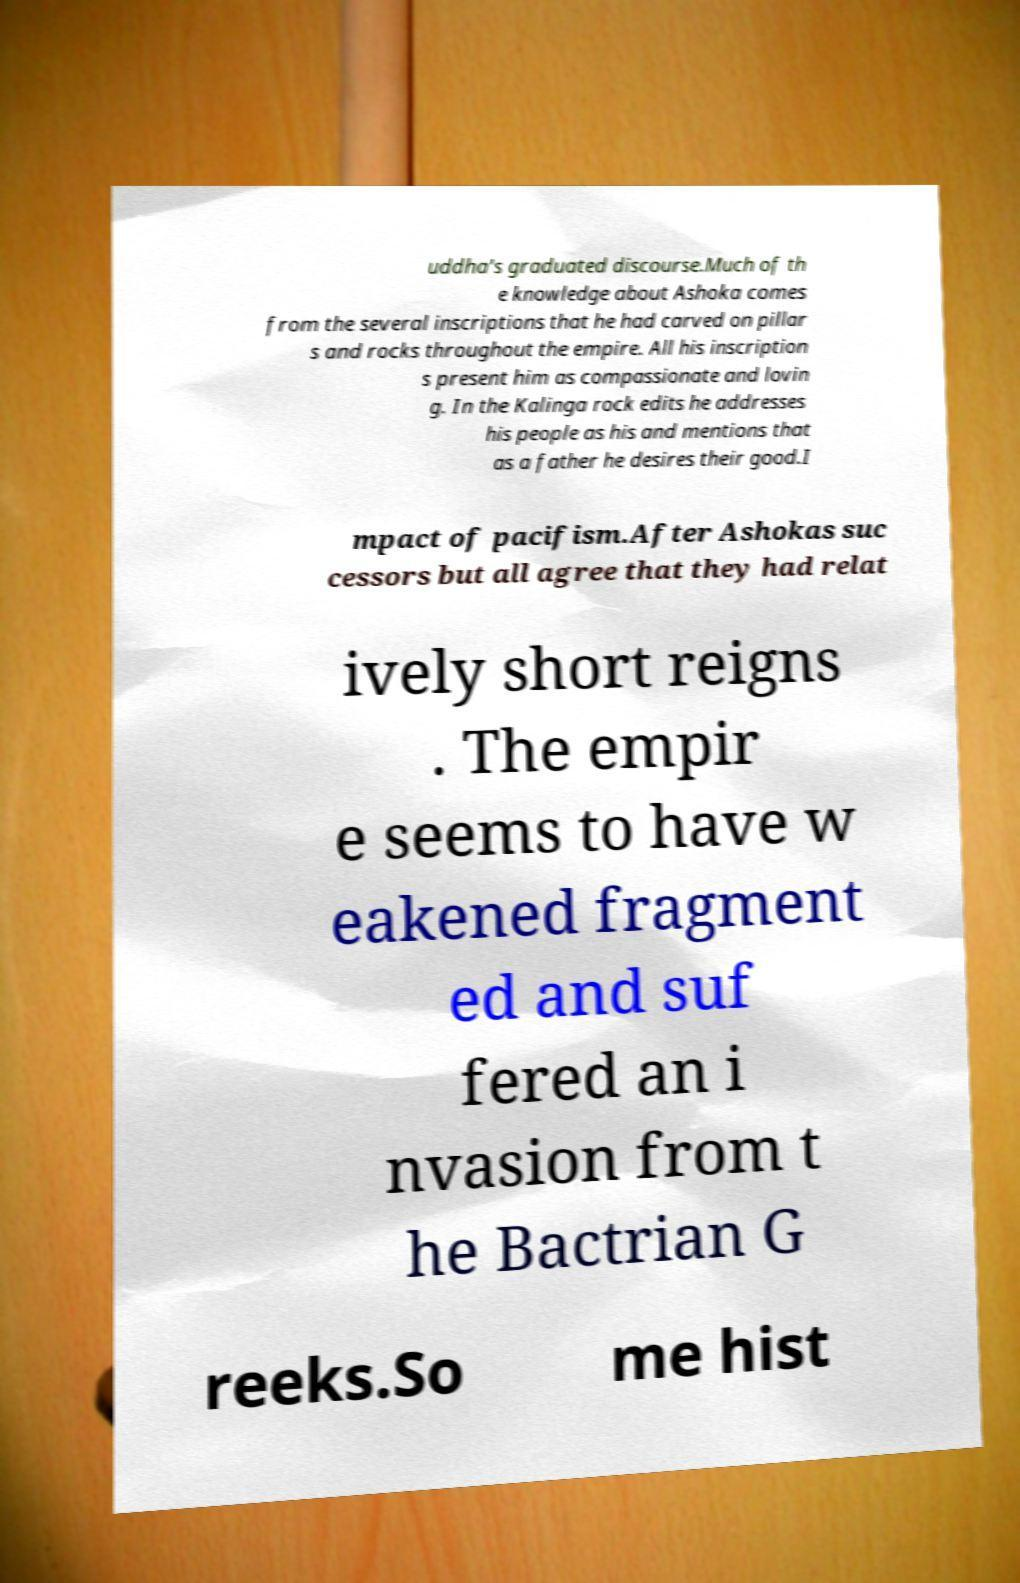Can you read and provide the text displayed in the image?This photo seems to have some interesting text. Can you extract and type it out for me? uddha's graduated discourse.Much of th e knowledge about Ashoka comes from the several inscriptions that he had carved on pillar s and rocks throughout the empire. All his inscription s present him as compassionate and lovin g. In the Kalinga rock edits he addresses his people as his and mentions that as a father he desires their good.I mpact of pacifism.After Ashokas suc cessors but all agree that they had relat ively short reigns . The empir e seems to have w eakened fragment ed and suf fered an i nvasion from t he Bactrian G reeks.So me hist 